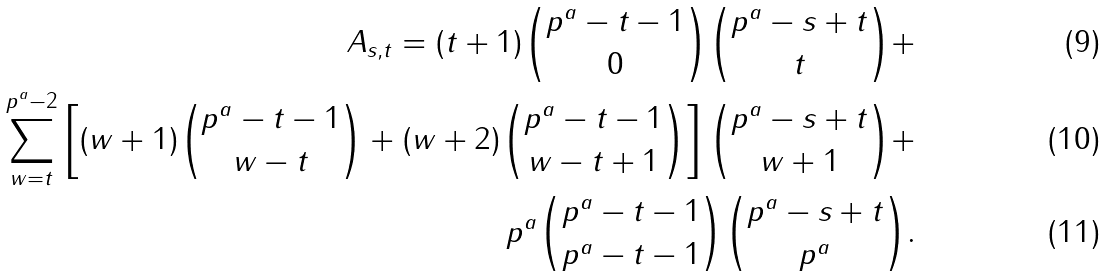Convert formula to latex. <formula><loc_0><loc_0><loc_500><loc_500>A _ { s , t } = ( t + 1 ) \binom { p ^ { a } - t - 1 } { 0 } \binom { p ^ { a } - s + t } { t } + \\ \sum _ { w = t } ^ { p ^ { a } - 2 } \left [ ( w + 1 ) \binom { p ^ { a } - t - 1 } { w - t } + ( w + 2 ) \binom { p ^ { a } - t - 1 } { w - t + 1 } \right ] \binom { p ^ { a } - s + t } { w + 1 } + \\ p ^ { a } \binom { p ^ { a } - t - 1 } { p ^ { a } - t - 1 } \binom { p ^ { a } - s + t } { p ^ { a } } .</formula> 